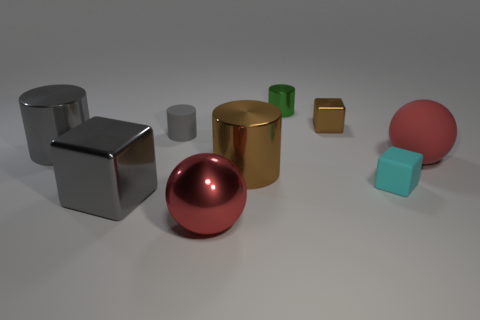Add 1 gray objects. How many objects exist? 10 Subtract all cubes. How many objects are left? 6 Subtract 0 red cylinders. How many objects are left? 9 Subtract all large red balls. Subtract all green cylinders. How many objects are left? 6 Add 2 gray cylinders. How many gray cylinders are left? 4 Add 6 big red metallic spheres. How many big red metallic spheres exist? 7 